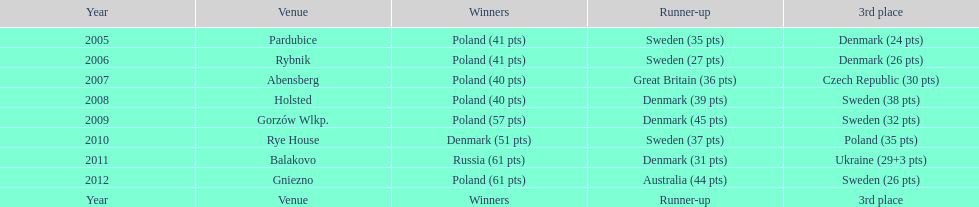Help me parse the entirety of this table. {'header': ['Year', 'Venue', 'Winners', 'Runner-up', '3rd place'], 'rows': [['2005', 'Pardubice', 'Poland (41 pts)', 'Sweden (35 pts)', 'Denmark (24 pts)'], ['2006', 'Rybnik', 'Poland (41 pts)', 'Sweden (27 pts)', 'Denmark (26 pts)'], ['2007', 'Abensberg', 'Poland (40 pts)', 'Great Britain (36 pts)', 'Czech Republic (30 pts)'], ['2008', 'Holsted', 'Poland (40 pts)', 'Denmark (39 pts)', 'Sweden (38 pts)'], ['2009', 'Gorzów Wlkp.', 'Poland (57 pts)', 'Denmark (45 pts)', 'Sweden (32 pts)'], ['2010', 'Rye House', 'Denmark (51 pts)', 'Sweden (37 pts)', 'Poland (35 pts)'], ['2011', 'Balakovo', 'Russia (61 pts)', 'Denmark (31 pts)', 'Ukraine (29+3 pts)'], ['2012', 'Gniezno', 'Poland (61 pts)', 'Australia (44 pts)', 'Sweden (26 pts)'], ['Year', 'Venue', 'Winners', 'Runner-up', '3rd place']]} After winning first place in 2009, how did poland perform at the speedway junior world championship the subsequent year? 3rd place. 